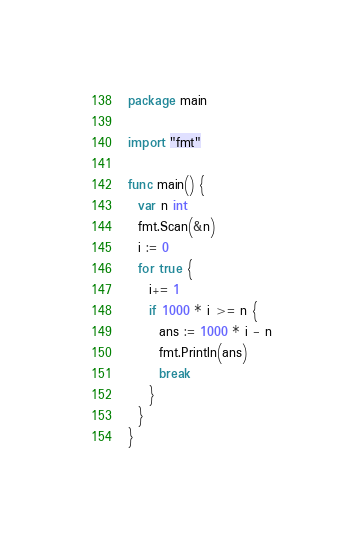Convert code to text. <code><loc_0><loc_0><loc_500><loc_500><_Go_>package main
 
import "fmt"
 
func main() {
  var n int
  fmt.Scan(&n)
  i := 0
  for true {
    i+= 1
    if 1000 * i >= n {
      ans := 1000 * i - n
      fmt.Println(ans)
      break
    }
  }
}</code> 